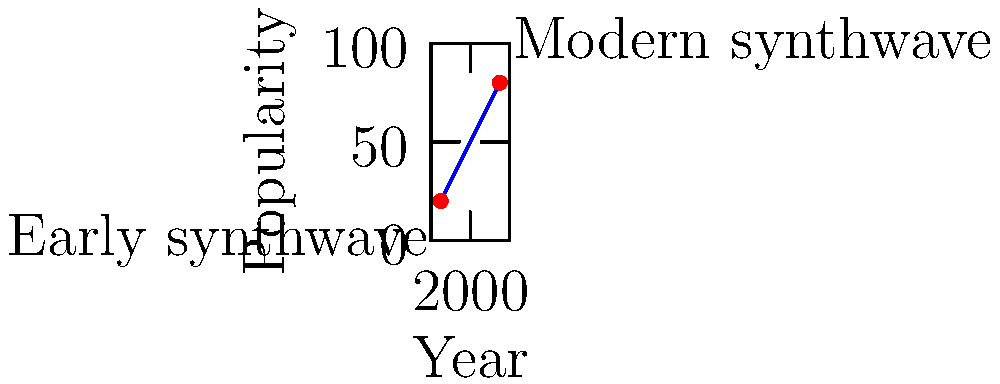In the graph above, two points represent different eras of synthwave music: early synthwave (1985, 20) and modern synthwave (2015, 80). Find the equation of the line passing through these two points in slope-intercept form $(y = mx + b)$, where $m$ represents the average annual increase in popularity and $b$ represents the theoretical popularity in the year 1980. To find the equation of the line passing through two points, we'll follow these steps:

1. Calculate the slope $(m)$ using the point-slope formula:
   $m = \frac{y_2 - y_1}{x_2 - x_1} = \frac{80 - 20}{2015 - 1985} = \frac{60}{30} = 2$

2. Use the point-slope form of a line with one of the points (let's use the first point):
   $y - y_1 = m(x - x_1)$
   $y - 20 = 2(x - 1985)$

3. Expand the equation:
   $y - 20 = 2x - 3970$

4. Solve for $y$ to get the slope-intercept form $(y = mx + b)$:
   $y = 2x - 3970 + 20$
   $y = 2x - 3950$

5. The $y$-intercept $(b)$ represents the theoretical popularity in 1980:
   $b = -3950$

Therefore, the equation of the line in slope-intercept form is:
$y = 2x - 3950$

where $m = 2$ (average annual increase in popularity) and $b = -3950$ (theoretical popularity in 1980).
Answer: $y = 2x - 3950$ 